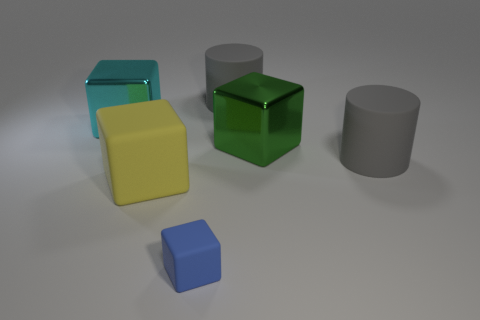Subtract 1 cubes. How many cubes are left? 3 Add 3 metal objects. How many objects exist? 9 Subtract all cubes. How many objects are left? 2 Add 5 big yellow blocks. How many big yellow blocks exist? 6 Subtract 0 yellow cylinders. How many objects are left? 6 Subtract all cylinders. Subtract all yellow objects. How many objects are left? 3 Add 1 gray objects. How many gray objects are left? 3 